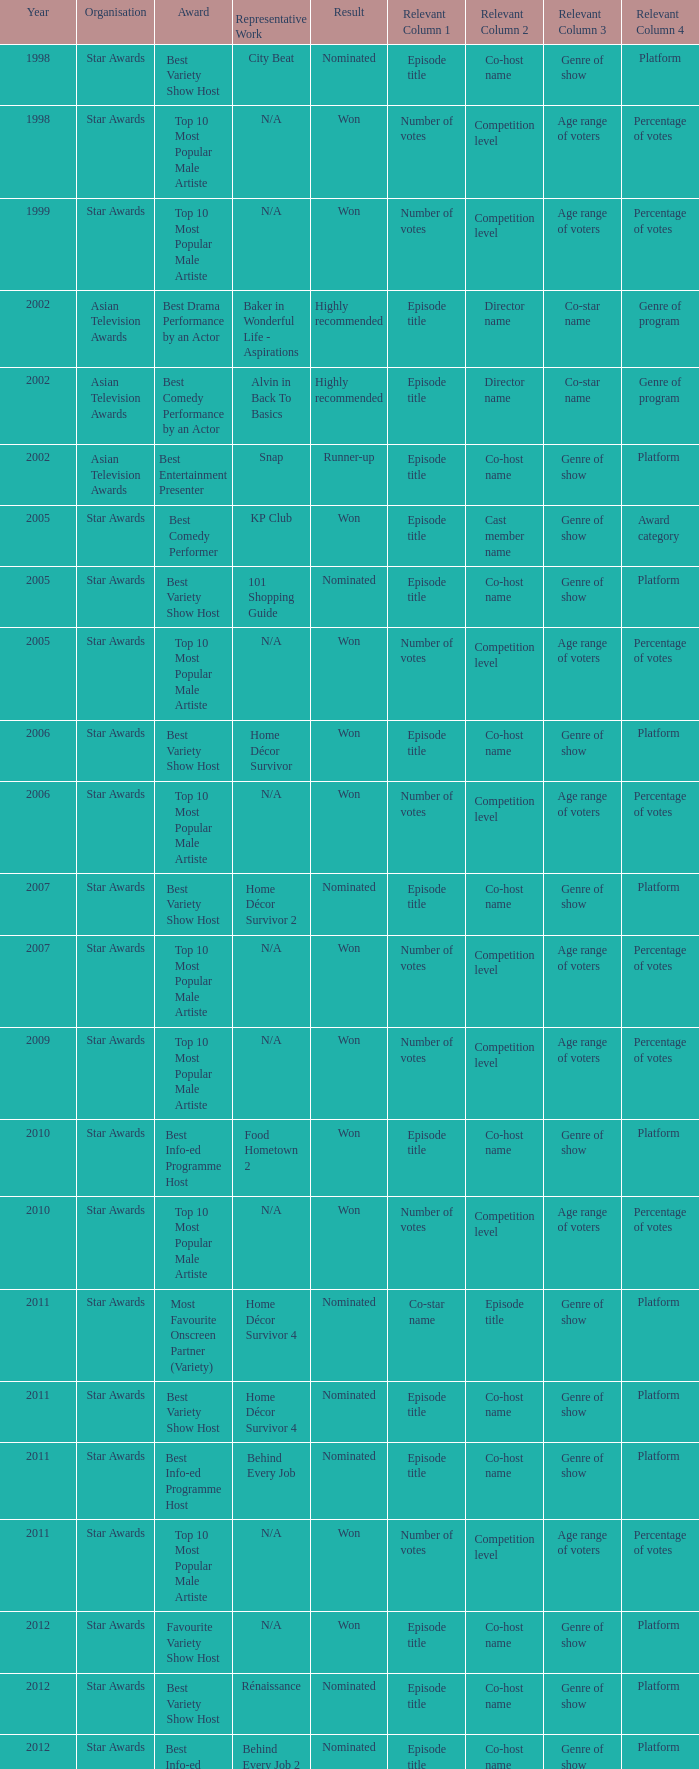What is the organisation in 2011 that was nominated and the award of best info-ed programme host? Star Awards. 